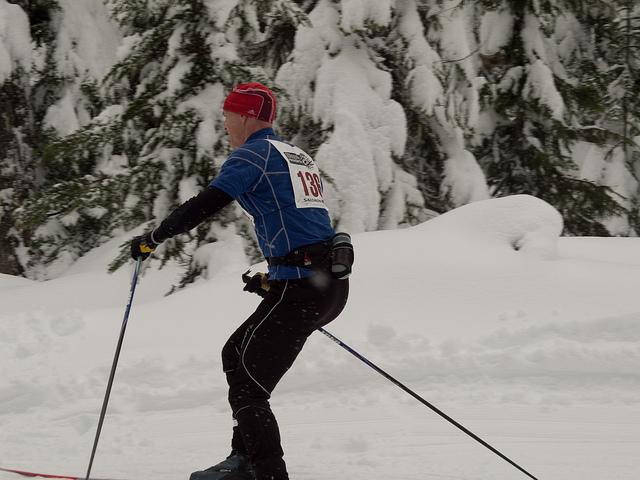Is this man skiing for fun?
Answer briefly. No. What color is the man's jacket?
Concise answer only. Blue. Are the people racing?
Be succinct. Yes. What number is on his back?
Quick response, please. 138. Does the man have facial hair?
Short answer required. No. Which way is the skier's right pole facing?
Short answer required. Back. What sport is this?
Write a very short answer. Skiing. Is the skier skiing downhill?
Write a very short answer. Yes. 